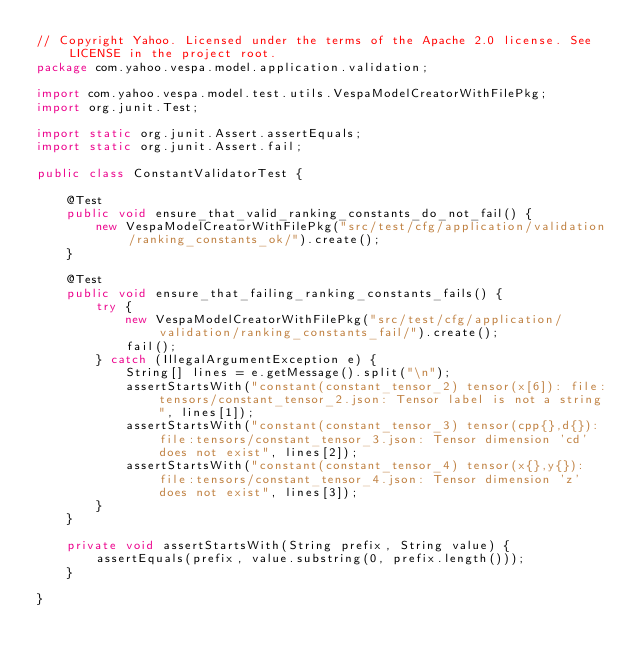Convert code to text. <code><loc_0><loc_0><loc_500><loc_500><_Java_>// Copyright Yahoo. Licensed under the terms of the Apache 2.0 license. See LICENSE in the project root.
package com.yahoo.vespa.model.application.validation;

import com.yahoo.vespa.model.test.utils.VespaModelCreatorWithFilePkg;
import org.junit.Test;

import static org.junit.Assert.assertEquals;
import static org.junit.Assert.fail;

public class ConstantValidatorTest {

    @Test
    public void ensure_that_valid_ranking_constants_do_not_fail() {
        new VespaModelCreatorWithFilePkg("src/test/cfg/application/validation/ranking_constants_ok/").create();
    }

    @Test
    public void ensure_that_failing_ranking_constants_fails() {
        try {
            new VespaModelCreatorWithFilePkg("src/test/cfg/application/validation/ranking_constants_fail/").create();
            fail();
        } catch (IllegalArgumentException e) {
            String[] lines = e.getMessage().split("\n");
            assertStartsWith("constant(constant_tensor_2) tensor(x[6]): file:tensors/constant_tensor_2.json: Tensor label is not a string", lines[1]);
            assertStartsWith("constant(constant_tensor_3) tensor(cpp{},d{}): file:tensors/constant_tensor_3.json: Tensor dimension 'cd' does not exist", lines[2]);
            assertStartsWith("constant(constant_tensor_4) tensor(x{},y{}): file:tensors/constant_tensor_4.json: Tensor dimension 'z' does not exist", lines[3]);
        }
    }

    private void assertStartsWith(String prefix, String value) {
        assertEquals(prefix, value.substring(0, prefix.length()));
    }

}
</code> 